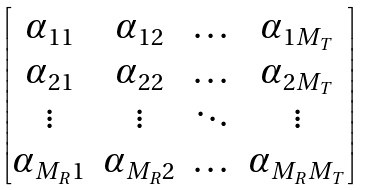Convert formula to latex. <formula><loc_0><loc_0><loc_500><loc_500>\begin{bmatrix} \alpha _ { 1 1 } & \alpha _ { 1 2 } & \dots & \alpha _ { 1 M _ { T } } \\ \alpha _ { 2 1 } & \alpha _ { 2 2 } & \dots & \alpha _ { 2 M _ { T } } \\ \vdots & \vdots & \ddots & \vdots \\ \alpha _ { M _ { R } 1 } & \alpha _ { M _ { R } 2 } & \dots & \alpha _ { M _ { R } M _ { T } } \end{bmatrix}</formula> 